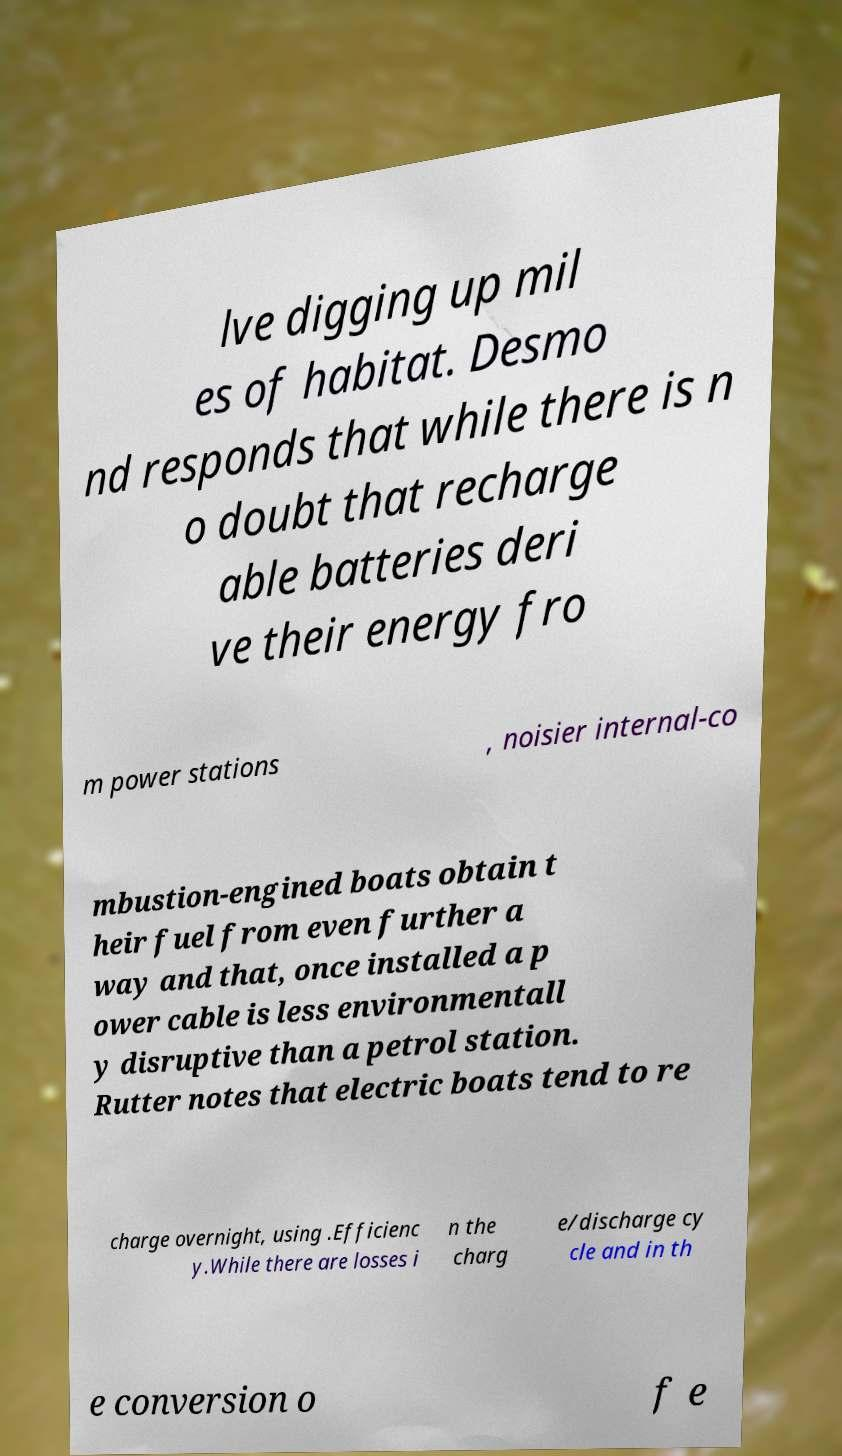Please identify and transcribe the text found in this image. lve digging up mil es of habitat. Desmo nd responds that while there is n o doubt that recharge able batteries deri ve their energy fro m power stations , noisier internal-co mbustion-engined boats obtain t heir fuel from even further a way and that, once installed a p ower cable is less environmentall y disruptive than a petrol station. Rutter notes that electric boats tend to re charge overnight, using .Efficienc y.While there are losses i n the charg e/discharge cy cle and in th e conversion o f e 